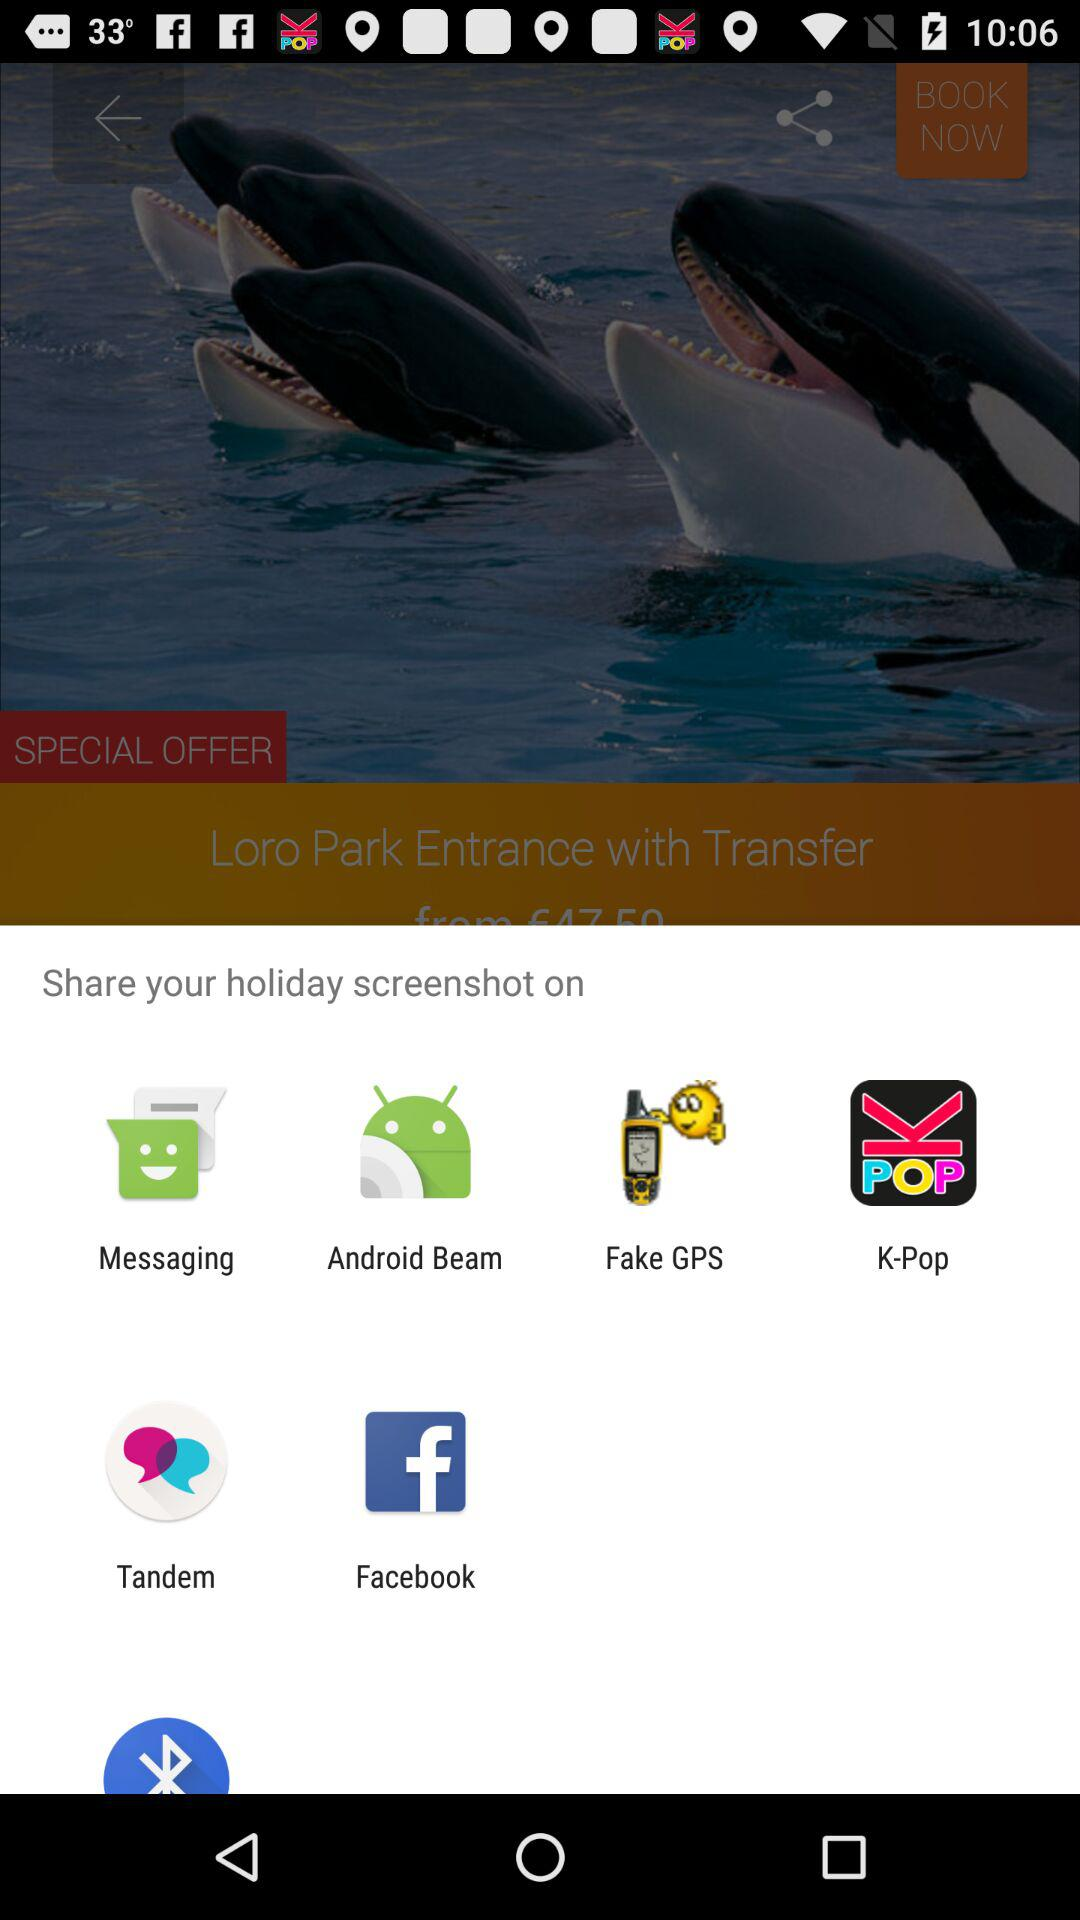Which applications allow us to share our holiday screenshot? You can share your holiday screenshot on "Messaging", "Android Beam", "Fake GPS", "K-Pop", "Tandem" and "Facebook". 